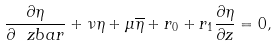<formula> <loc_0><loc_0><loc_500><loc_500>\frac { \partial \eta } { \partial \ z b a r } + \nu \eta + \mu \overline { \eta } + { r } _ { 0 } + { r } _ { 1 } \frac { \partial \eta } { \partial z } = 0 ,</formula> 